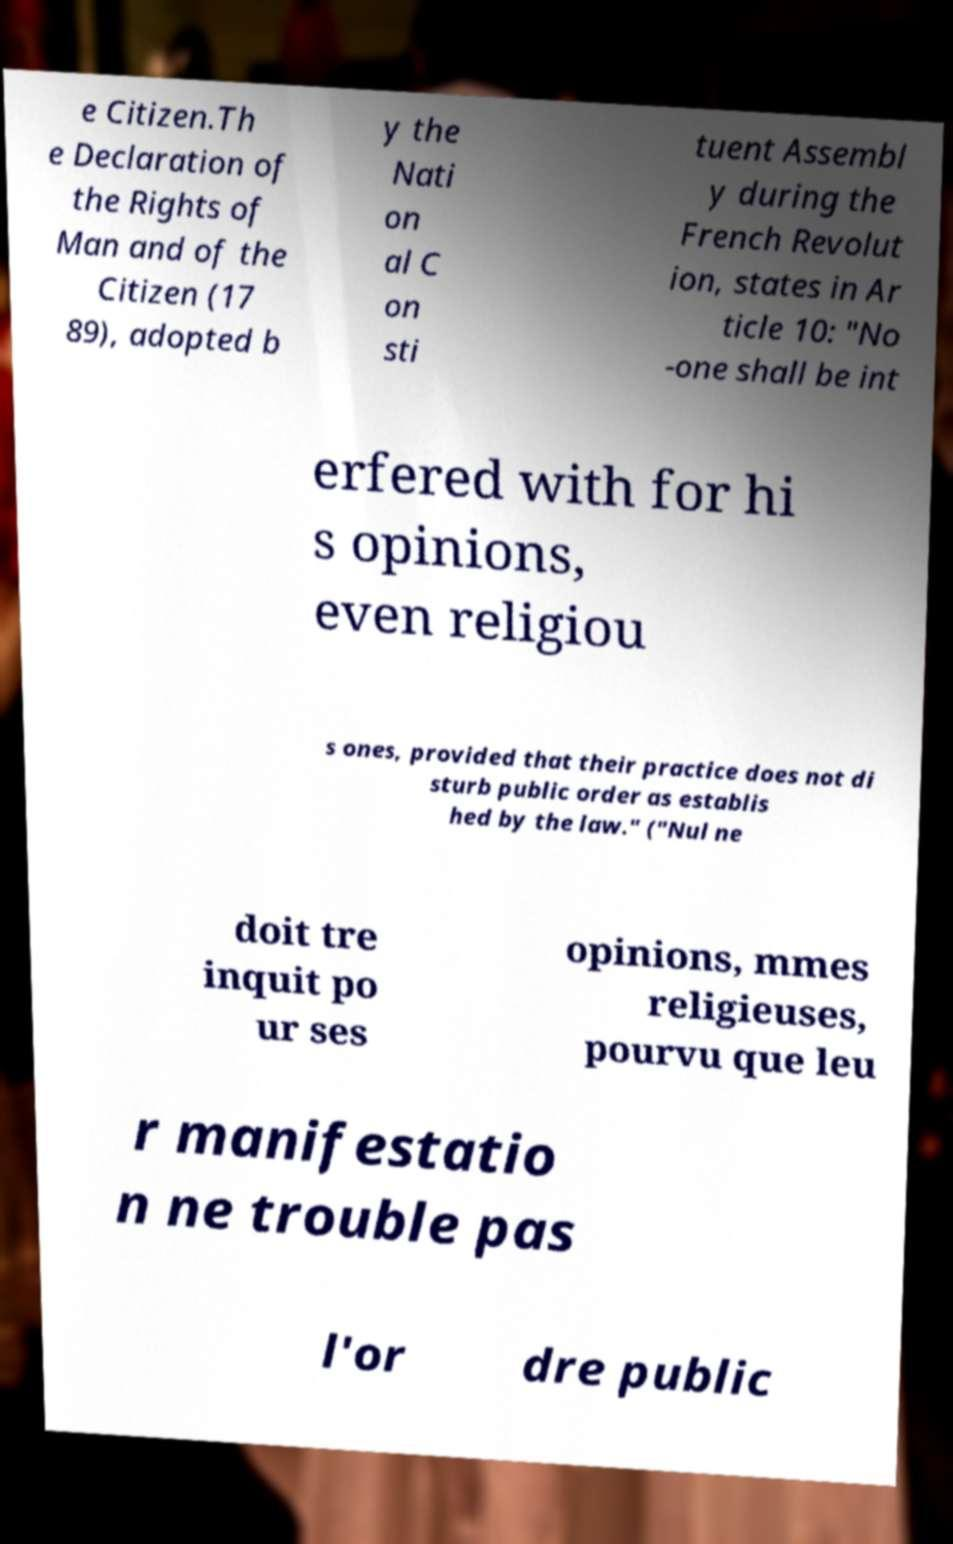Please identify and transcribe the text found in this image. e Citizen.Th e Declaration of the Rights of Man and of the Citizen (17 89), adopted b y the Nati on al C on sti tuent Assembl y during the French Revolut ion, states in Ar ticle 10: "No -one shall be int erfered with for hi s opinions, even religiou s ones, provided that their practice does not di sturb public order as establis hed by the law." ("Nul ne doit tre inquit po ur ses opinions, mmes religieuses, pourvu que leu r manifestatio n ne trouble pas l'or dre public 